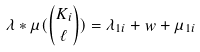Convert formula to latex. <formula><loc_0><loc_0><loc_500><loc_500>\lambda \ast \mu ( \binom { K _ { i } } { \ell } ) = \lambda _ { 1 i } + w + \mu _ { 1 i }</formula> 